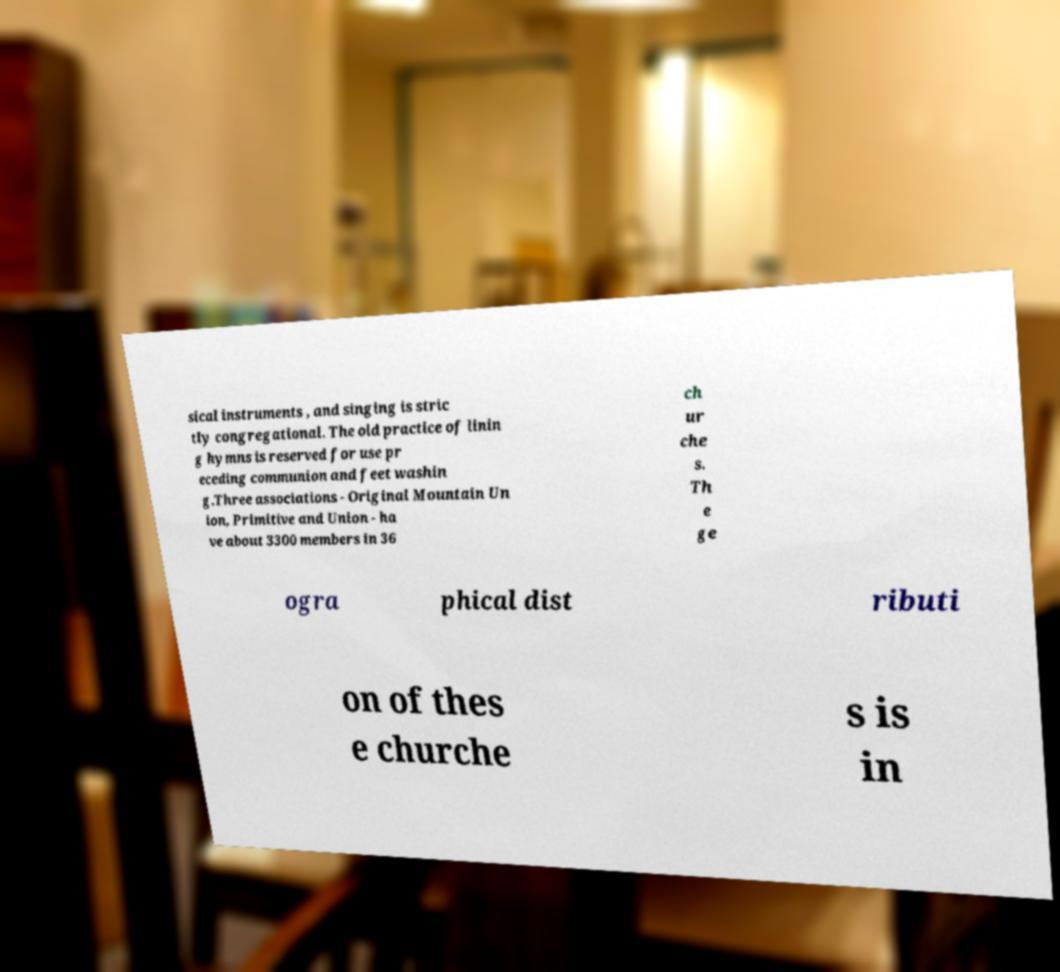Could you extract and type out the text from this image? sical instruments , and singing is stric tly congregational. The old practice of linin g hymns is reserved for use pr eceding communion and feet washin g.Three associations - Original Mountain Un ion, Primitive and Union - ha ve about 3300 members in 36 ch ur che s. Th e ge ogra phical dist ributi on of thes e churche s is in 